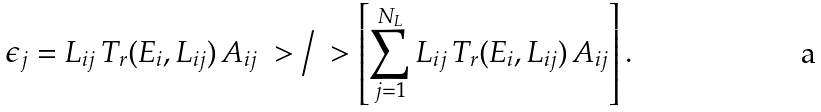Convert formula to latex. <formula><loc_0><loc_0><loc_500><loc_500>\epsilon _ { j } = L _ { i j } \, T _ { r } ( E _ { i } , L _ { i j } ) \, A _ { i j } \ > \Big / \ > \left [ \sum _ { j = 1 } ^ { N _ { L } } L _ { i j } \, T _ { r } ( E _ { i } , L _ { i j } ) \, A _ { i j } \right ] .</formula> 